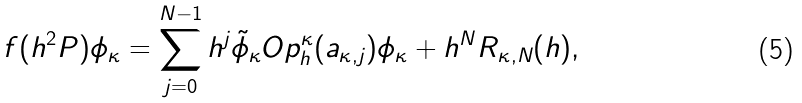Convert formula to latex. <formula><loc_0><loc_0><loc_500><loc_500>f ( h ^ { 2 } P ) \phi _ { \kappa } = \sum _ { j = 0 } ^ { N - 1 } h ^ { j } \tilde { \phi } _ { \kappa } O p ^ { \kappa } _ { h } ( a _ { \kappa , j } ) \phi _ { \kappa } + h ^ { N } R _ { \kappa , N } ( h ) ,</formula> 